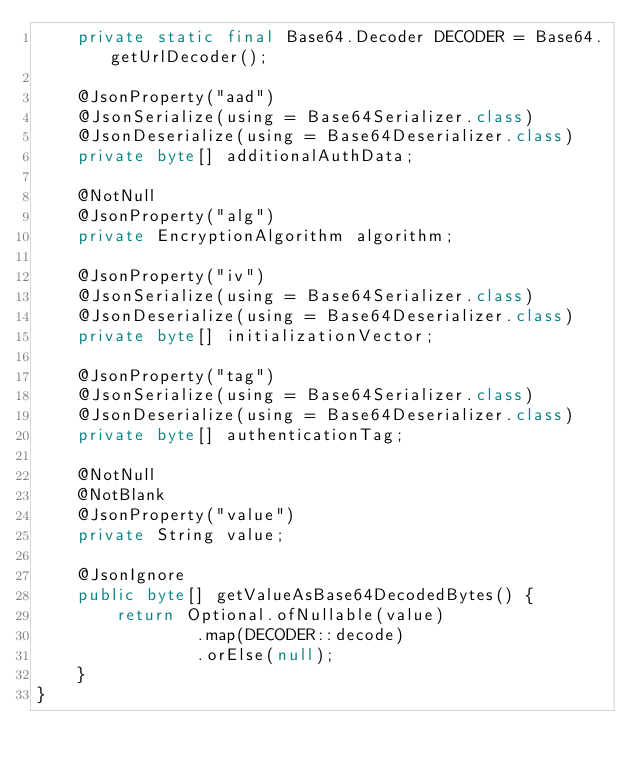Convert code to text. <code><loc_0><loc_0><loc_500><loc_500><_Java_>    private static final Base64.Decoder DECODER = Base64.getUrlDecoder();

    @JsonProperty("aad")
    @JsonSerialize(using = Base64Serializer.class)
    @JsonDeserialize(using = Base64Deserializer.class)
    private byte[] additionalAuthData;

    @NotNull
    @JsonProperty("alg")
    private EncryptionAlgorithm algorithm;

    @JsonProperty("iv")
    @JsonSerialize(using = Base64Serializer.class)
    @JsonDeserialize(using = Base64Deserializer.class)
    private byte[] initializationVector;

    @JsonProperty("tag")
    @JsonSerialize(using = Base64Serializer.class)
    @JsonDeserialize(using = Base64Deserializer.class)
    private byte[] authenticationTag;

    @NotNull
    @NotBlank
    @JsonProperty("value")
    private String value;

    @JsonIgnore
    public byte[] getValueAsBase64DecodedBytes() {
        return Optional.ofNullable(value)
                .map(DECODER::decode)
                .orElse(null);
    }
}
</code> 